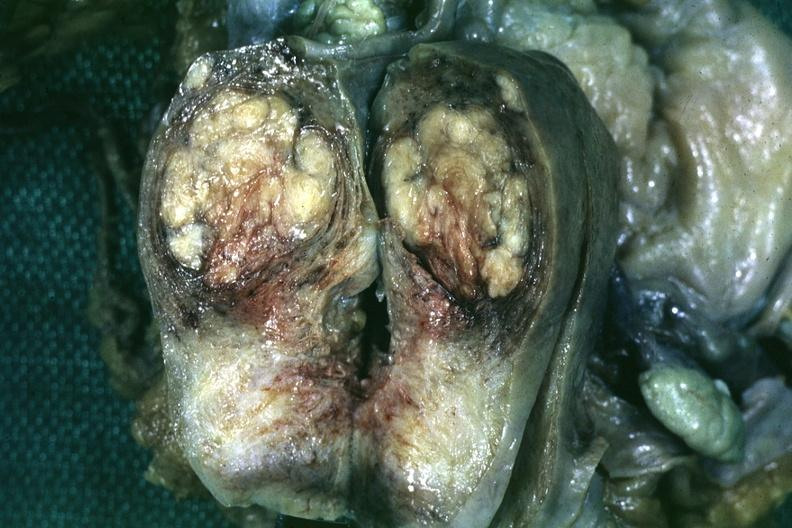s female reproductive present?
Answer the question using a single word or phrase. Yes 